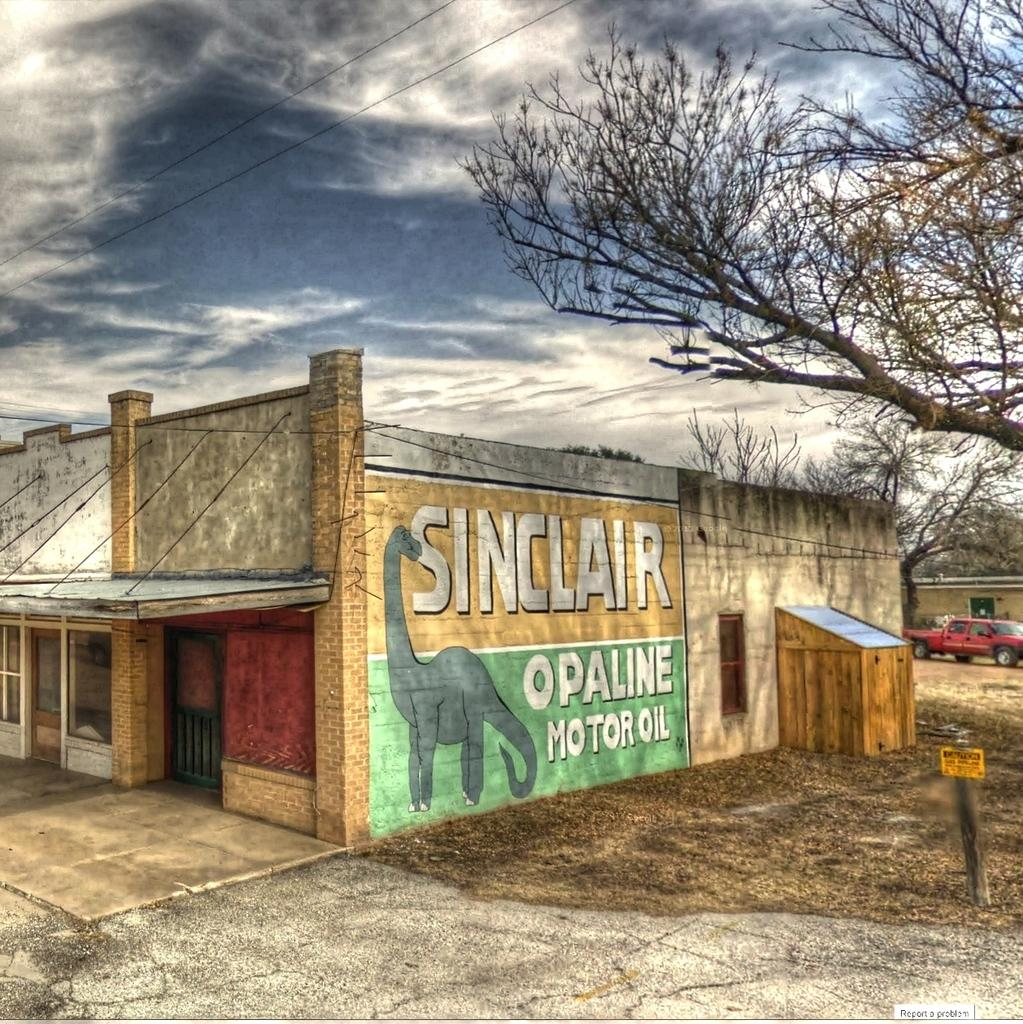What type of structures can be seen in the image? There are buildings in the image. What is the tall, vertical object in the image? There is a pole in the image. What is located on the ground in the image? There is a vehicle on the ground in the image. What type of vegetation is present in the image? There are trees in the image. What type of artwork is visible in the image? There is a painting on a wall in the image. What else can be seen in the image besides the mentioned objects? There are some objects in the image. What is visible in the background of the image? The sky with clouds is visible in the background of the image. What type of toothpaste is being used by the monkey in the image? There is no monkey or toothpaste present in the image. What force is being applied to the vehicle in the image? There is no indication of any force being applied to the vehicle in the image; it is stationary on the ground. 